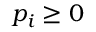<formula> <loc_0><loc_0><loc_500><loc_500>p _ { i } \geq 0</formula> 